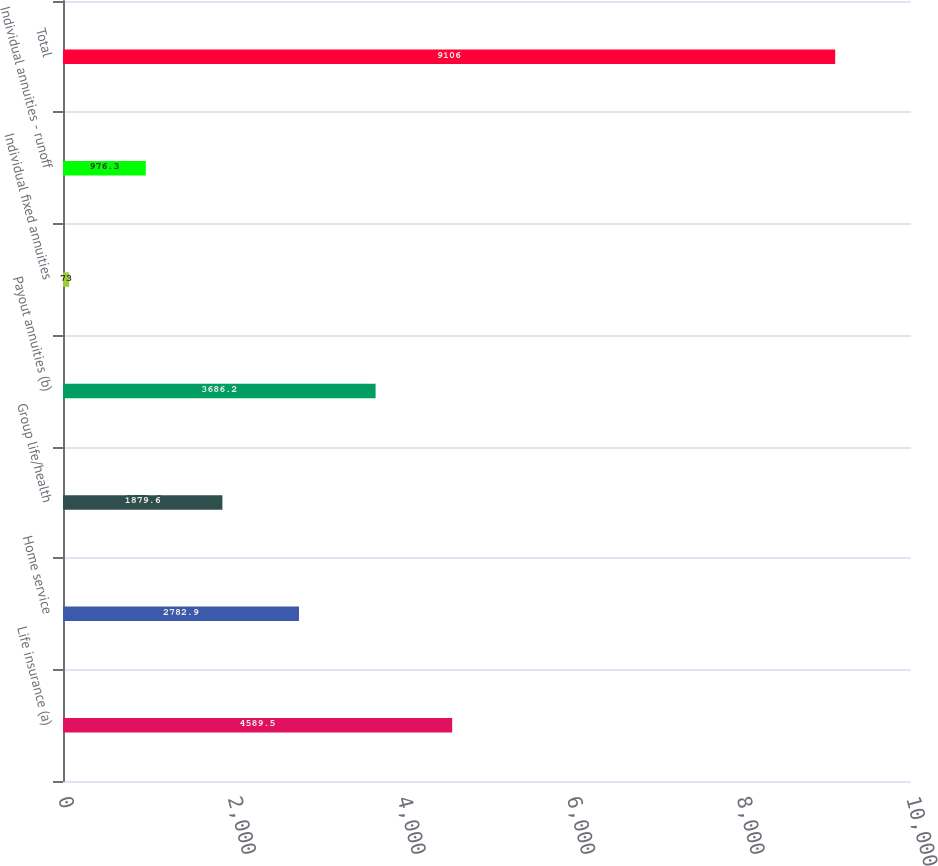Convert chart. <chart><loc_0><loc_0><loc_500><loc_500><bar_chart><fcel>Life insurance (a)<fcel>Home service<fcel>Group life/health<fcel>Payout annuities (b)<fcel>Individual fixed annuities<fcel>Individual annuities - runoff<fcel>Total<nl><fcel>4589.5<fcel>2782.9<fcel>1879.6<fcel>3686.2<fcel>73<fcel>976.3<fcel>9106<nl></chart> 